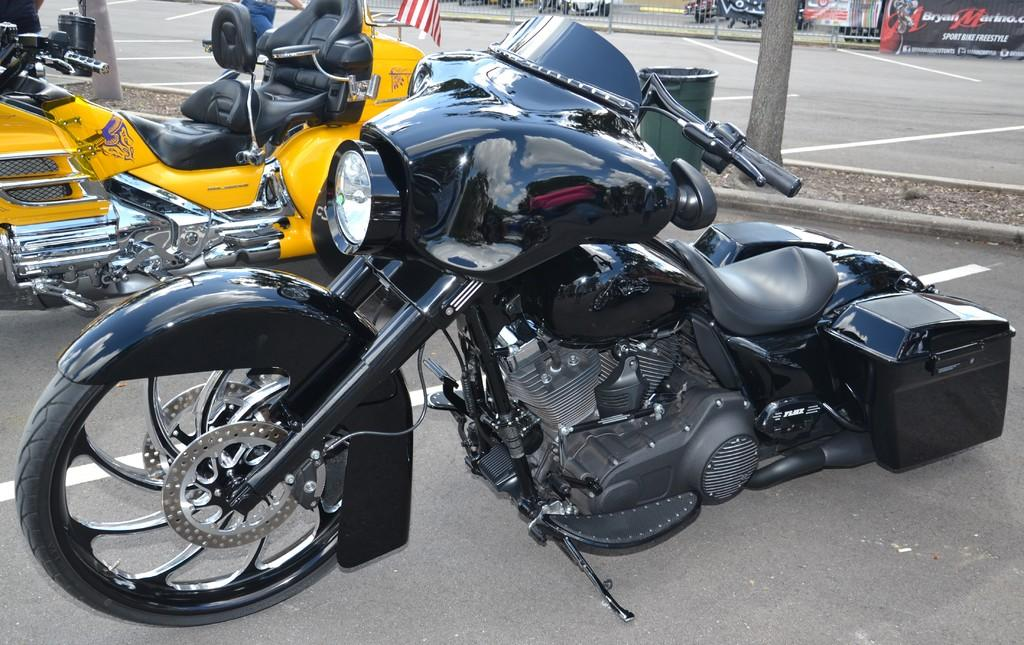What can be seen on the road in the image? There are vehicles on the road in the image. Can you describe the person in the image? There is a person in the image. What is the flag associated with in the image? There is a flag in the image. What is used for disposing of waste in the image? There is a dustbin in the image. What can be seen in the background of the image? In the background of the image, there are banners and a fence. Are there any other objects visible in the background of the image? Yes, there are other objects visible in the background of the image. Can you tell me how many grains of sand are on the person's shoes in the image? There is no sand or reference to sand in the image, so it is not possible to determine the number of grains on the person's shoes. What type of ant can be seen crawling on the flag in the image? There are no ants present in the image, and therefore no such activity can be observed. 